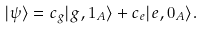<formula> <loc_0><loc_0><loc_500><loc_500>| \psi \rangle = c _ { g } | g , 1 _ { A } \rangle + c _ { e } | e , 0 _ { A } \rangle .</formula> 